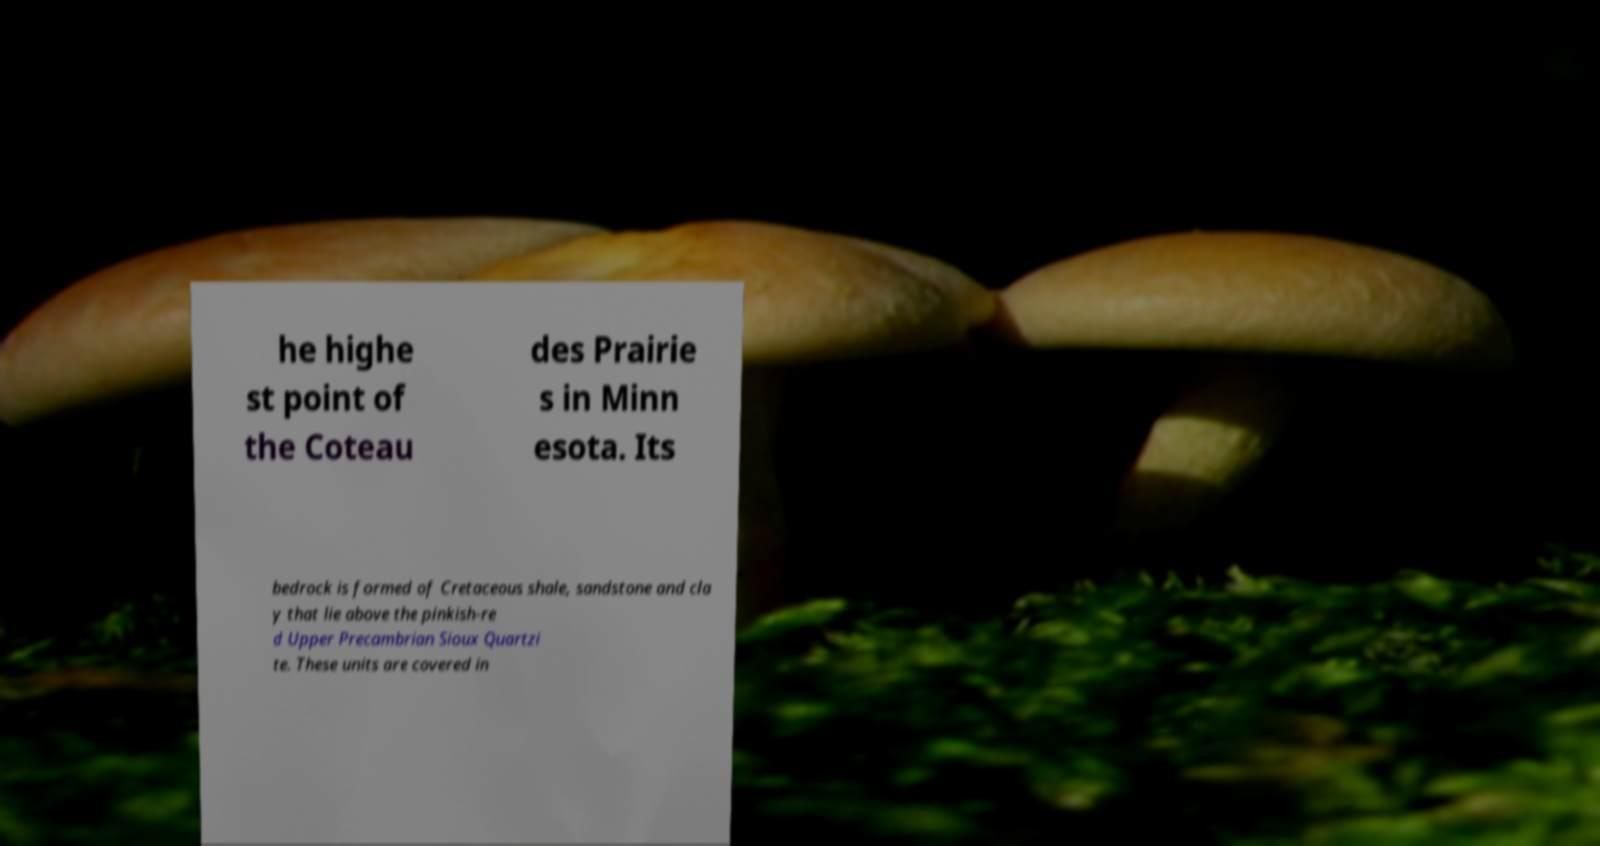There's text embedded in this image that I need extracted. Can you transcribe it verbatim? he highe st point of the Coteau des Prairie s in Minn esota. Its bedrock is formed of Cretaceous shale, sandstone and cla y that lie above the pinkish-re d Upper Precambrian Sioux Quartzi te. These units are covered in 